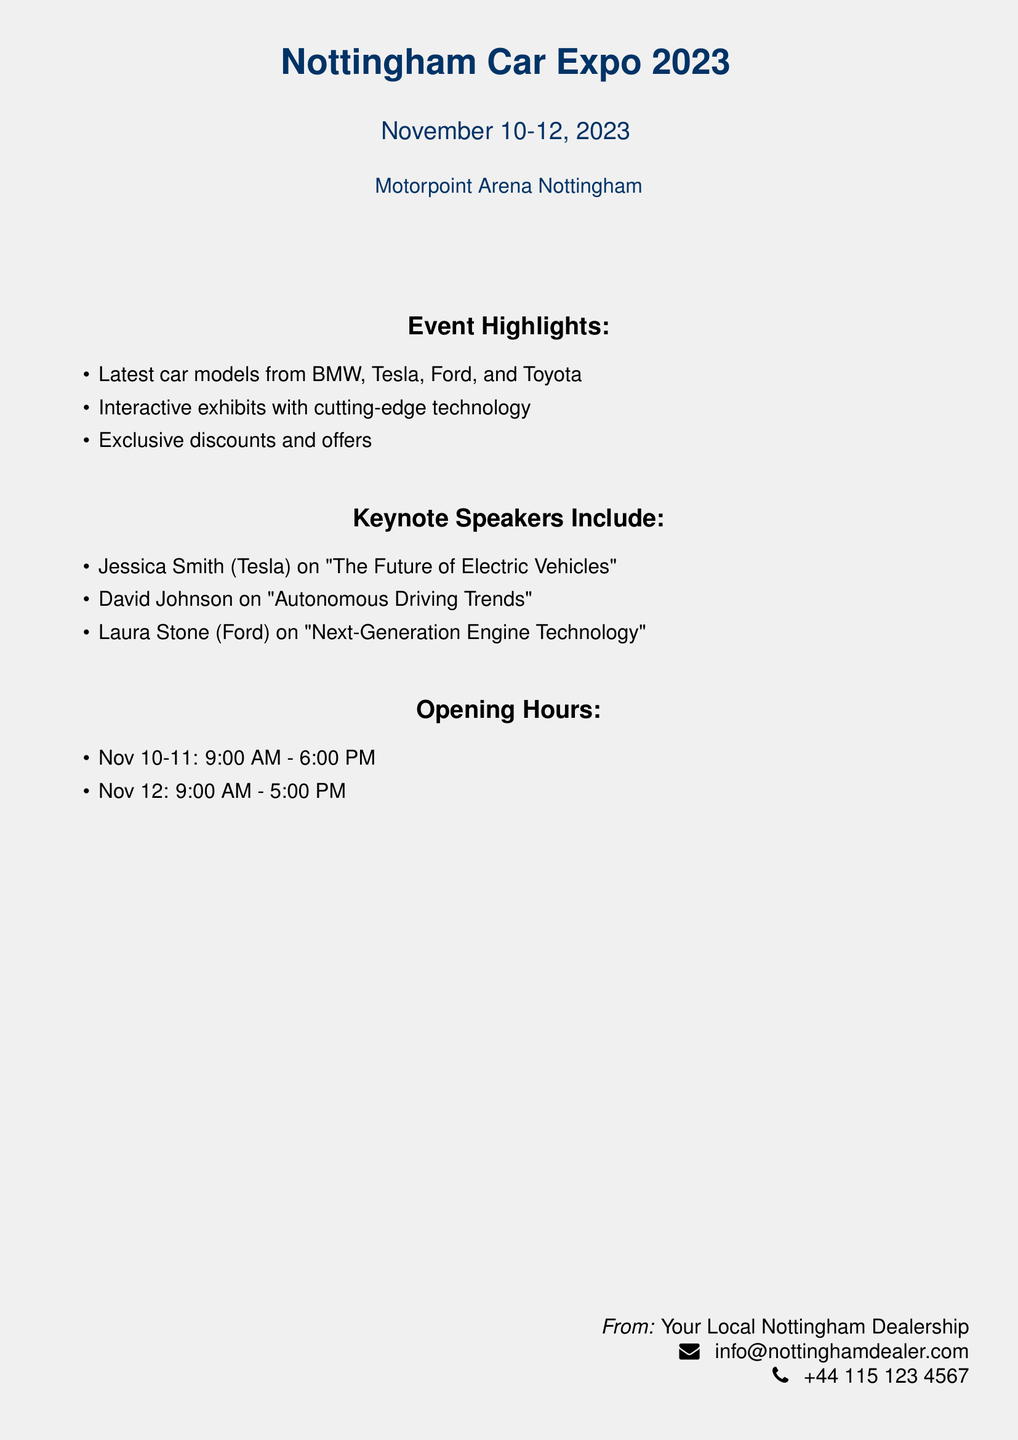What are the dates of the event? The dates of the event are specified at the top of the document, listing the days it will occur.
Answer: November 10-12, 2023 Where is the expo taking place? The location of the expo is provided in the document, indicating the venue.
Answer: Motorpoint Arena Nottingham Who is the keynote speaker on electric vehicles? The document lists keynote speakers and their topics, including which speaker focuses on electric vehicles.
Answer: Jessica Smith What are the opening hours on November 11? The document includes specific opening hours for each day of the event, so this can be directly found.
Answer: 9:00 AM - 6:00 PM What type of technology will be featured in the exhibits? The event highlights mention the focus of some exhibits, specifically regarding technology.
Answer: Cutting-edge technology How many days is the expo running? The first line of the event's date provides the duration the expo spans.
Answer: Three days What is an exclusive offer mentioned in the highlights? The event highlights mention this aspect but do not specify what the offers are, requiring logical inference from the phrase.
Answer: Discounts Who is speaking about next-generation engine technology? The keynote speakers section explicitly lists speakers along with their topics, which include engine technology.
Answer: Laura Stone What time does the expo close on November 12? The opening hours for each day include the closing time for November 12.
Answer: 5:00 PM 